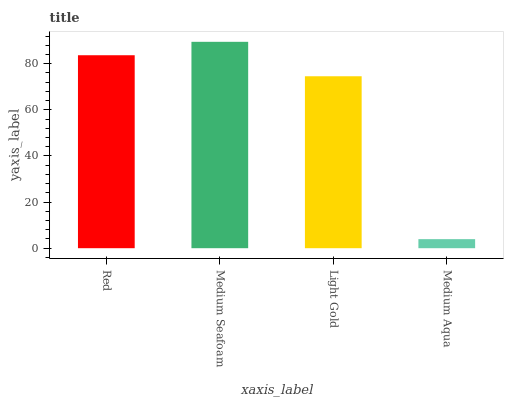Is Medium Aqua the minimum?
Answer yes or no. Yes. Is Medium Seafoam the maximum?
Answer yes or no. Yes. Is Light Gold the minimum?
Answer yes or no. No. Is Light Gold the maximum?
Answer yes or no. No. Is Medium Seafoam greater than Light Gold?
Answer yes or no. Yes. Is Light Gold less than Medium Seafoam?
Answer yes or no. Yes. Is Light Gold greater than Medium Seafoam?
Answer yes or no. No. Is Medium Seafoam less than Light Gold?
Answer yes or no. No. Is Red the high median?
Answer yes or no. Yes. Is Light Gold the low median?
Answer yes or no. Yes. Is Light Gold the high median?
Answer yes or no. No. Is Red the low median?
Answer yes or no. No. 